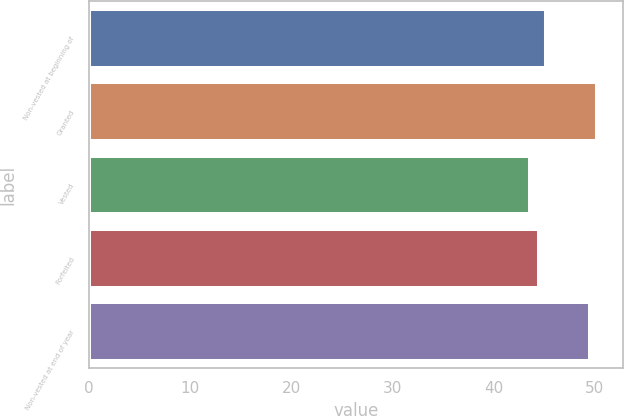Convert chart. <chart><loc_0><loc_0><loc_500><loc_500><bar_chart><fcel>Non-vested at beginning of<fcel>Granted<fcel>Vested<fcel>Forfeited<fcel>Non-vested at end of year<nl><fcel>45.16<fcel>50.26<fcel>43.59<fcel>44.45<fcel>49.56<nl></chart> 